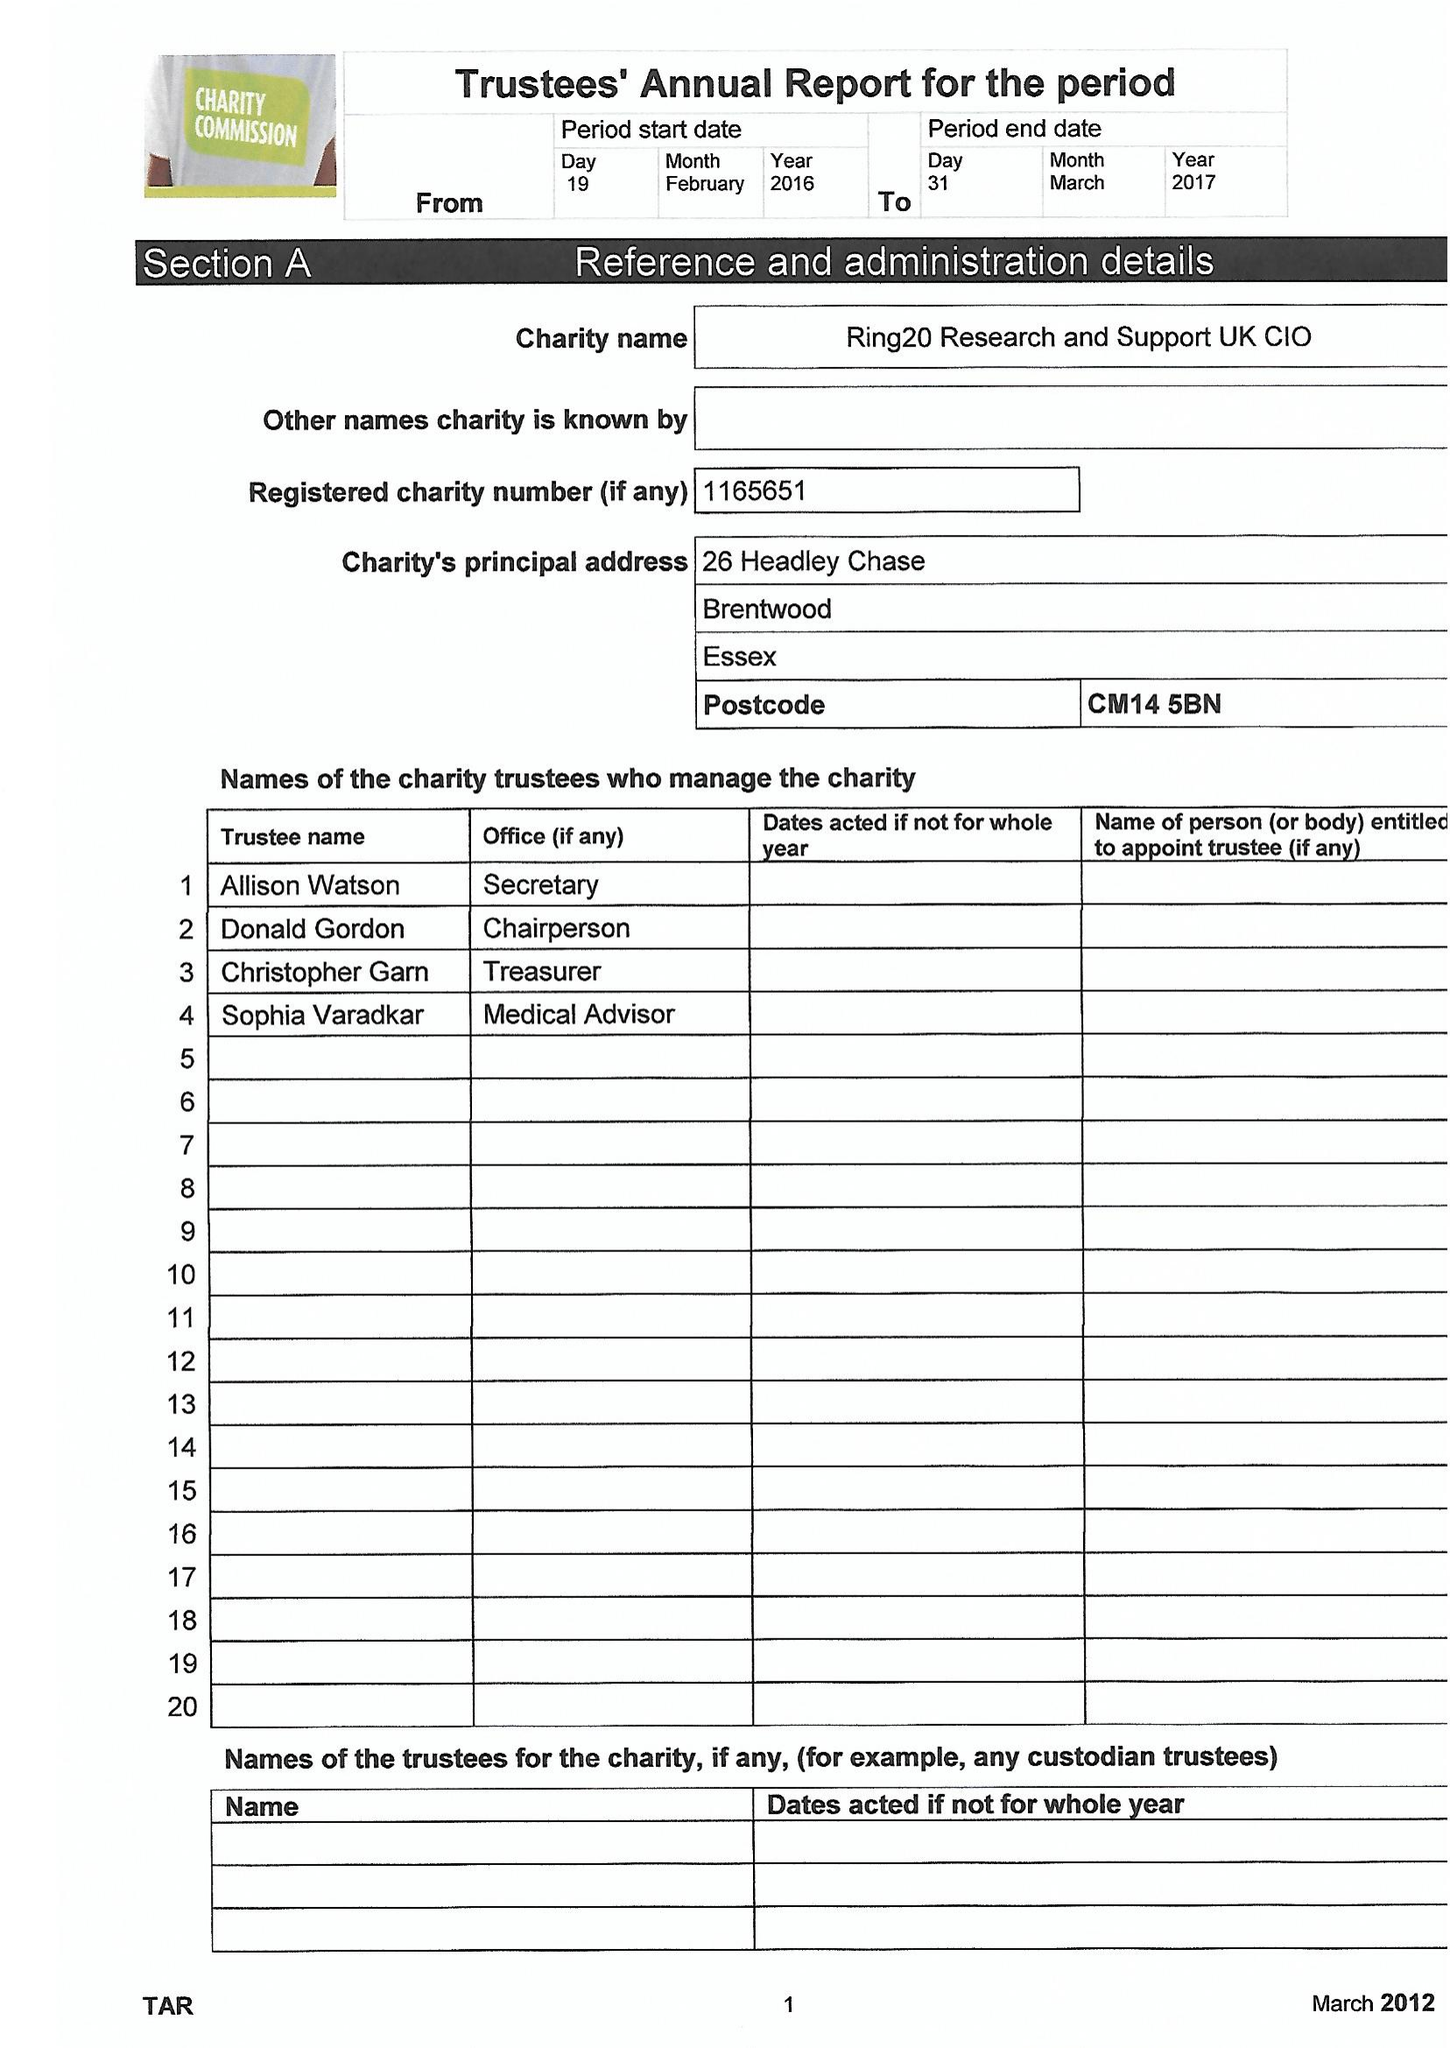What is the value for the address__postcode?
Answer the question using a single word or phrase. CM14 5BN 